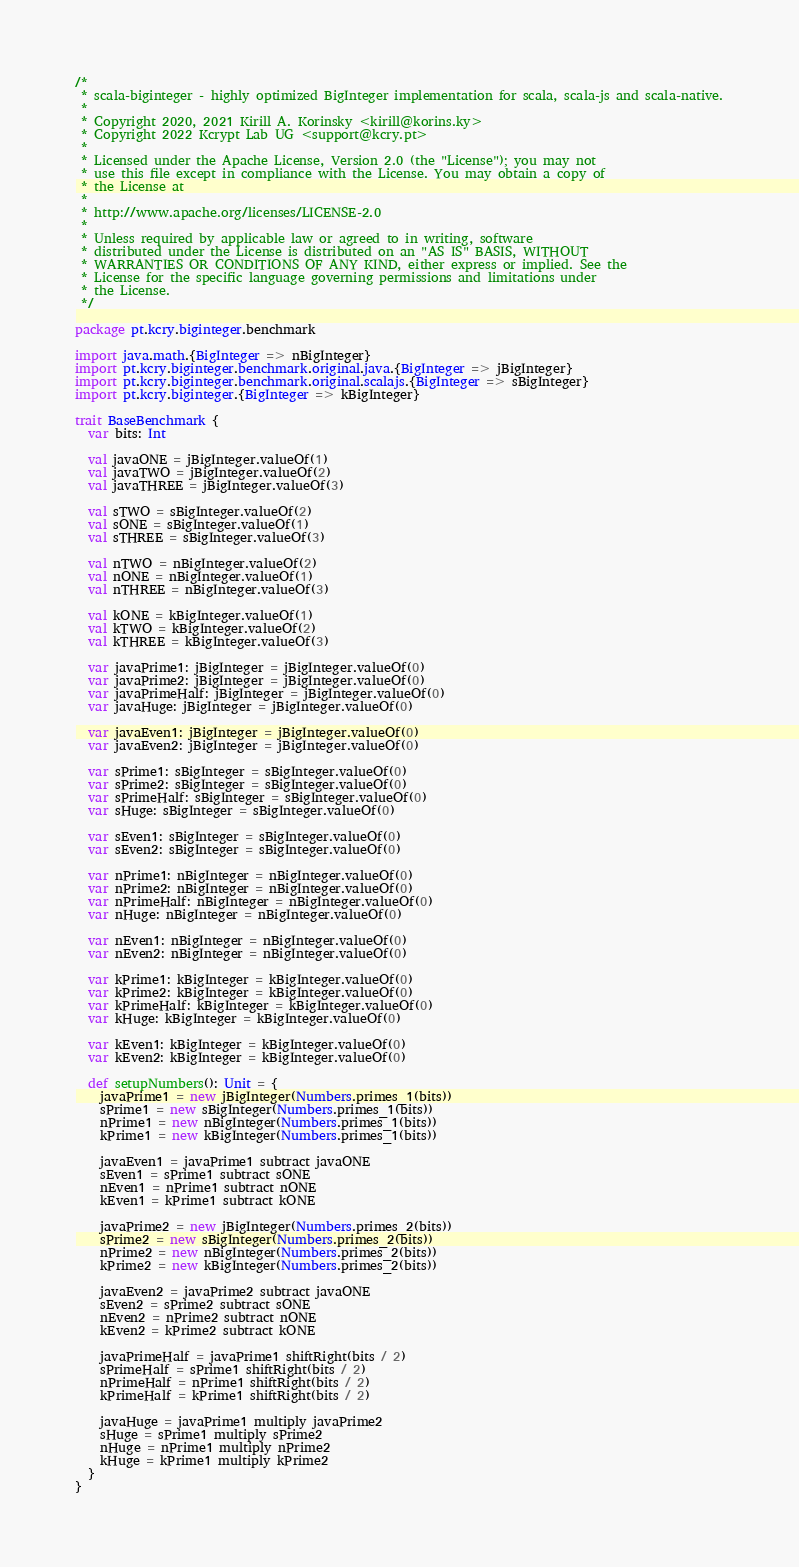<code> <loc_0><loc_0><loc_500><loc_500><_Scala_>/*
 * scala-biginteger - highly optimized BigInteger implementation for scala, scala-js and scala-native.
 *
 * Copyright 2020, 2021 Kirill A. Korinsky <kirill@korins.ky>
 * Copyright 2022 Kcrypt Lab UG <support@kcry.pt>
 *
 * Licensed under the Apache License, Version 2.0 (the "License"); you may not
 * use this file except in compliance with the License. You may obtain a copy of
 * the License at
 *
 * http://www.apache.org/licenses/LICENSE-2.0
 *
 * Unless required by applicable law or agreed to in writing, software
 * distributed under the License is distributed on an "AS IS" BASIS, WITHOUT
 * WARRANTIES OR CONDITIONS OF ANY KIND, either express or implied. See the
 * License for the specific language governing permissions and limitations under
 * the License.
 */

package pt.kcry.biginteger.benchmark

import java.math.{BigInteger => nBigInteger}
import pt.kcry.biginteger.benchmark.original.java.{BigInteger => jBigInteger}
import pt.kcry.biginteger.benchmark.original.scalajs.{BigInteger => sBigInteger}
import pt.kcry.biginteger.{BigInteger => kBigInteger}

trait BaseBenchmark {
  var bits: Int

  val javaONE = jBigInteger.valueOf(1)
  val javaTWO = jBigInteger.valueOf(2)
  val javaTHREE = jBigInteger.valueOf(3)

  val sTWO = sBigInteger.valueOf(2)
  val sONE = sBigInteger.valueOf(1)
  val sTHREE = sBigInteger.valueOf(3)

  val nTWO = nBigInteger.valueOf(2)
  val nONE = nBigInteger.valueOf(1)
  val nTHREE = nBigInteger.valueOf(3)

  val kONE = kBigInteger.valueOf(1)
  val kTWO = kBigInteger.valueOf(2)
  val kTHREE = kBigInteger.valueOf(3)

  var javaPrime1: jBigInteger = jBigInteger.valueOf(0)
  var javaPrime2: jBigInteger = jBigInteger.valueOf(0)
  var javaPrimeHalf: jBigInteger = jBigInteger.valueOf(0)
  var javaHuge: jBigInteger = jBigInteger.valueOf(0)

  var javaEven1: jBigInteger = jBigInteger.valueOf(0)
  var javaEven2: jBigInteger = jBigInteger.valueOf(0)

  var sPrime1: sBigInteger = sBigInteger.valueOf(0)
  var sPrime2: sBigInteger = sBigInteger.valueOf(0)
  var sPrimeHalf: sBigInteger = sBigInteger.valueOf(0)
  var sHuge: sBigInteger = sBigInteger.valueOf(0)

  var sEven1: sBigInteger = sBigInteger.valueOf(0)
  var sEven2: sBigInteger = sBigInteger.valueOf(0)

  var nPrime1: nBigInteger = nBigInteger.valueOf(0)
  var nPrime2: nBigInteger = nBigInteger.valueOf(0)
  var nPrimeHalf: nBigInteger = nBigInteger.valueOf(0)
  var nHuge: nBigInteger = nBigInteger.valueOf(0)

  var nEven1: nBigInteger = nBigInteger.valueOf(0)
  var nEven2: nBigInteger = nBigInteger.valueOf(0)

  var kPrime1: kBigInteger = kBigInteger.valueOf(0)
  var kPrime2: kBigInteger = kBigInteger.valueOf(0)
  var kPrimeHalf: kBigInteger = kBigInteger.valueOf(0)
  var kHuge: kBigInteger = kBigInteger.valueOf(0)

  var kEven1: kBigInteger = kBigInteger.valueOf(0)
  var kEven2: kBigInteger = kBigInteger.valueOf(0)

  def setupNumbers(): Unit = {
    javaPrime1 = new jBigInteger(Numbers.primes_1(bits))
    sPrime1 = new sBigInteger(Numbers.primes_1(bits))
    nPrime1 = new nBigInteger(Numbers.primes_1(bits))
    kPrime1 = new kBigInteger(Numbers.primes_1(bits))

    javaEven1 = javaPrime1 subtract javaONE
    sEven1 = sPrime1 subtract sONE
    nEven1 = nPrime1 subtract nONE
    kEven1 = kPrime1 subtract kONE

    javaPrime2 = new jBigInteger(Numbers.primes_2(bits))
    sPrime2 = new sBigInteger(Numbers.primes_2(bits))
    nPrime2 = new nBigInteger(Numbers.primes_2(bits))
    kPrime2 = new kBigInteger(Numbers.primes_2(bits))

    javaEven2 = javaPrime2 subtract javaONE
    sEven2 = sPrime2 subtract sONE
    nEven2 = nPrime2 subtract nONE
    kEven2 = kPrime2 subtract kONE

    javaPrimeHalf = javaPrime1 shiftRight(bits / 2)
    sPrimeHalf = sPrime1 shiftRight(bits / 2)
    nPrimeHalf = nPrime1 shiftRight(bits / 2)
    kPrimeHalf = kPrime1 shiftRight(bits / 2)

    javaHuge = javaPrime1 multiply javaPrime2
    sHuge = sPrime1 multiply sPrime2
    nHuge = nPrime1 multiply nPrime2
    kHuge = kPrime1 multiply kPrime2
  }
}
</code> 